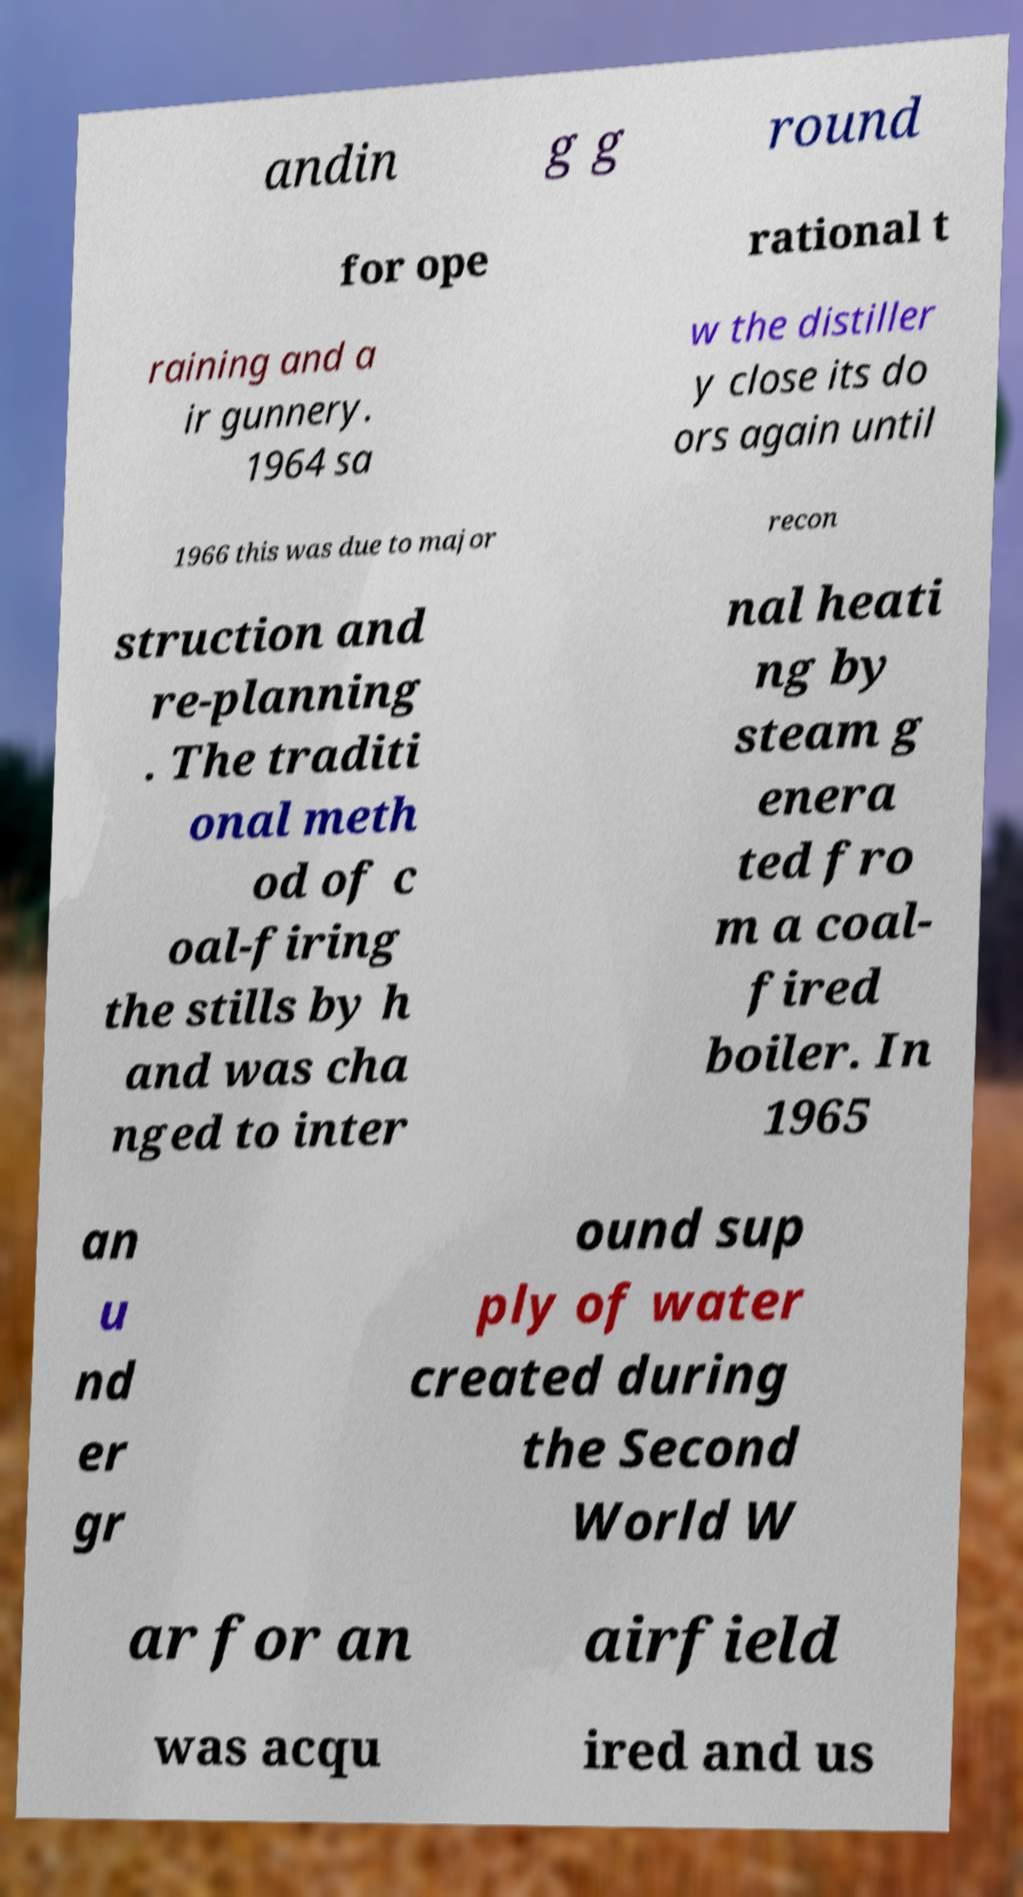Can you accurately transcribe the text from the provided image for me? andin g g round for ope rational t raining and a ir gunnery. 1964 sa w the distiller y close its do ors again until 1966 this was due to major recon struction and re-planning . The traditi onal meth od of c oal-firing the stills by h and was cha nged to inter nal heati ng by steam g enera ted fro m a coal- fired boiler. In 1965 an u nd er gr ound sup ply of water created during the Second World W ar for an airfield was acqu ired and us 